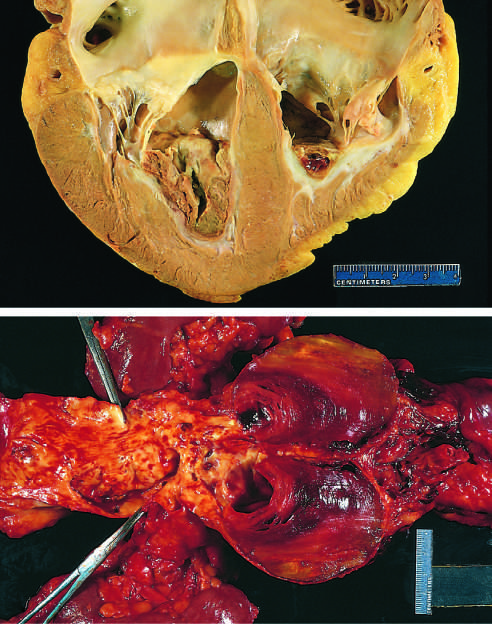does thrombus in the left and right ventricular apices overlie white fibrous scar?
Answer the question using a single word or phrase. Yes 